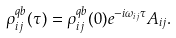Convert formula to latex. <formula><loc_0><loc_0><loc_500><loc_500>\rho ^ { q b } _ { i j } ( \tau ) = \rho ^ { q b } _ { i j } ( 0 ) e ^ { - i \omega _ { i j } \tau } A _ { i j } .</formula> 